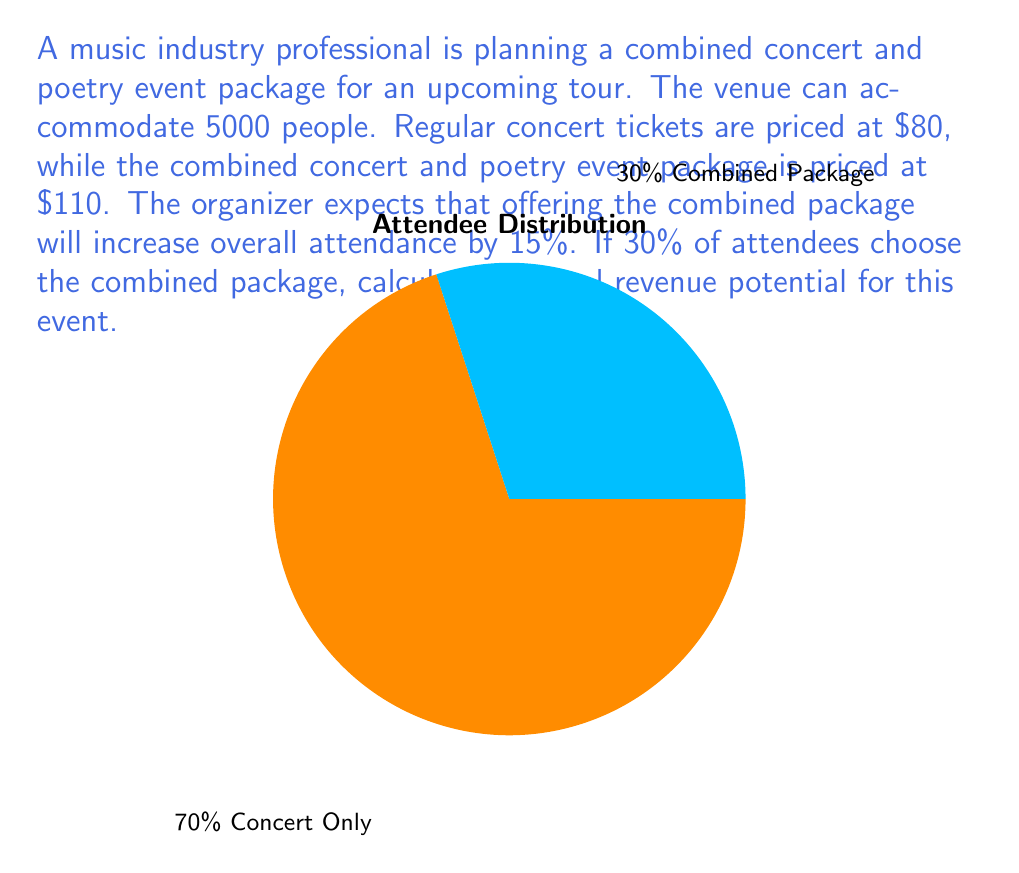Teach me how to tackle this problem. Let's approach this problem step-by-step:

1) First, calculate the expected attendance with the combined package offer:
   Base capacity: 5000
   Increase: 15% = 0.15
   Expected attendance: $5000 \times (1 + 0.15) = 5750$ people

2) Now, split the attendees into two groups:
   Combined package: 30% = $0.30 \times 5750 = 1725$ people
   Concert only: 70% = $0.70 \times 5750 = 4025$ people

3) Calculate the revenue from each group:
   Combined package revenue: $1725 \times \$110 = \$189,750$
   Concert only revenue: $4025 \times \$80 = \$322,000$

4) Sum up the total revenue:
   Total revenue = Combined package revenue + Concert only revenue
   $$ \text{Total revenue} = \$189,750 + \$322,000 = \$511,750 $$

Therefore, the total revenue potential for this event is $511,750.
Answer: $511,750 